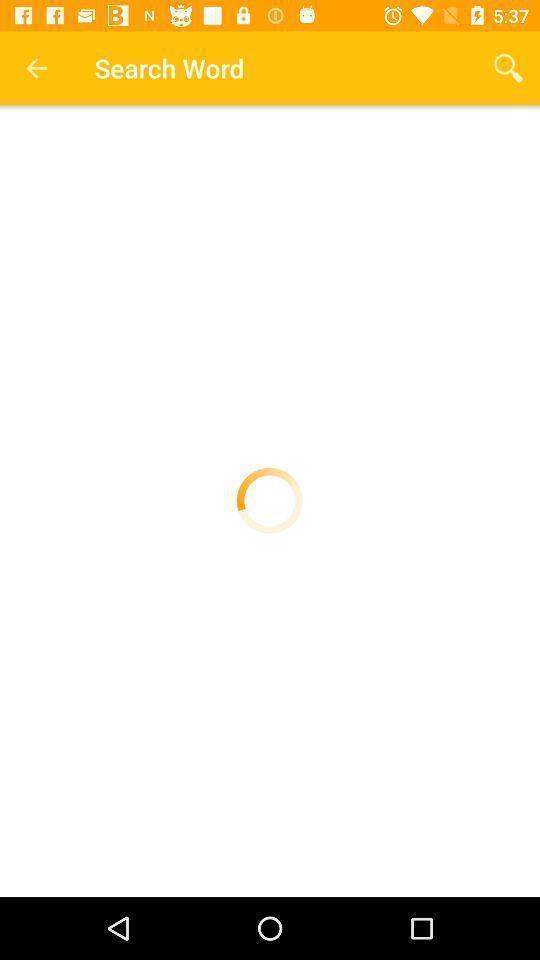Please provide a description for this image. Screen shows search world with loading page. 